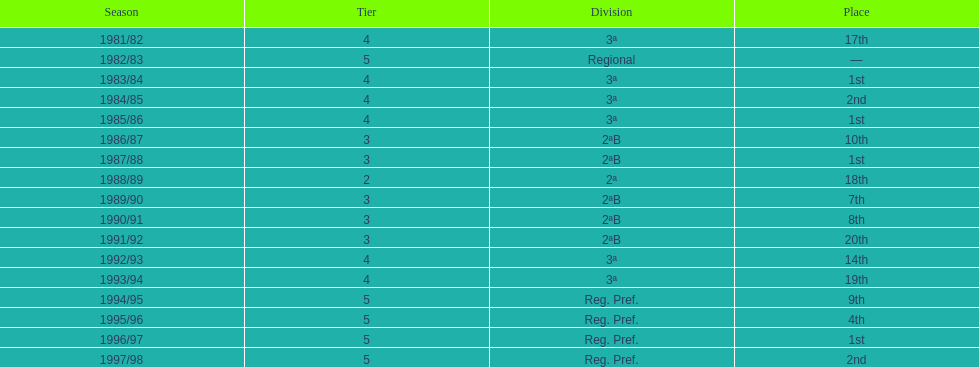How many years were they in tier 3 5. 